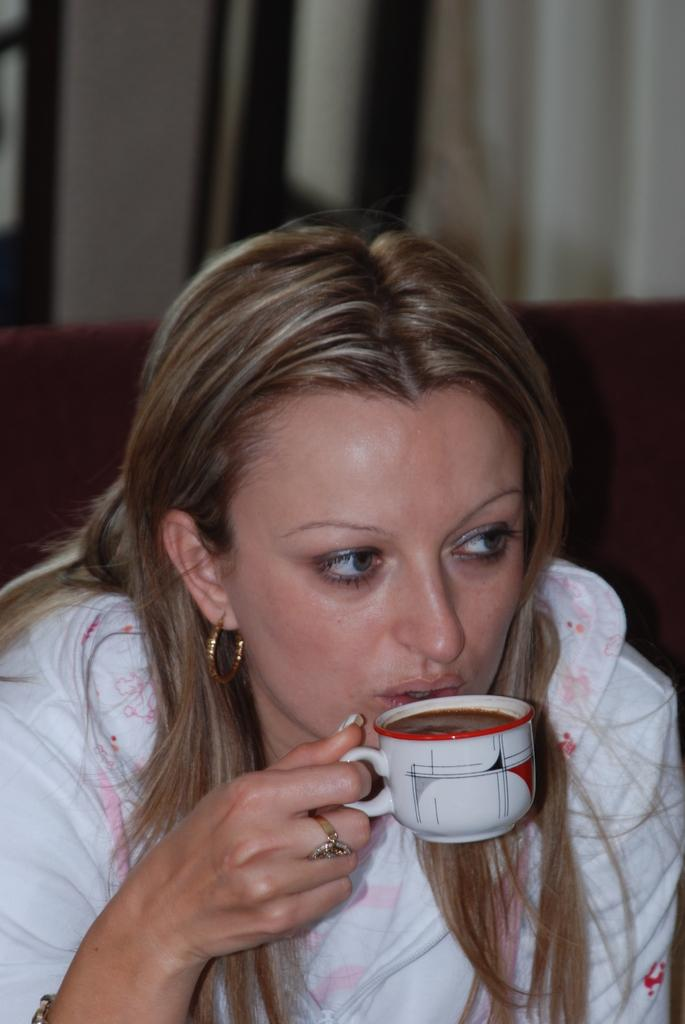Who is the main subject in the image? There is a lady in the center of the image. What is the lady holding in her hand? The lady is holding a cup in her hand. What can be seen in the background of the image? There is a curtain in the background of the image. What type of stamp can be seen on the lady's arm in the image? There is no stamp visible on the lady's arm in the image. How many muscles can be seen flexing on the lady's arm in the image? There is no indication of muscles or their flexing on the lady's arm in the image. 